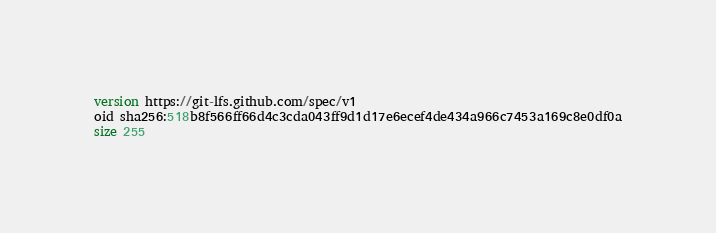<code> <loc_0><loc_0><loc_500><loc_500><_SQL_>version https://git-lfs.github.com/spec/v1
oid sha256:518b8f566ff66d4c3cda043ff9d1d17e6ecef4de434a966c7453a169c8e0df0a
size 255
</code> 